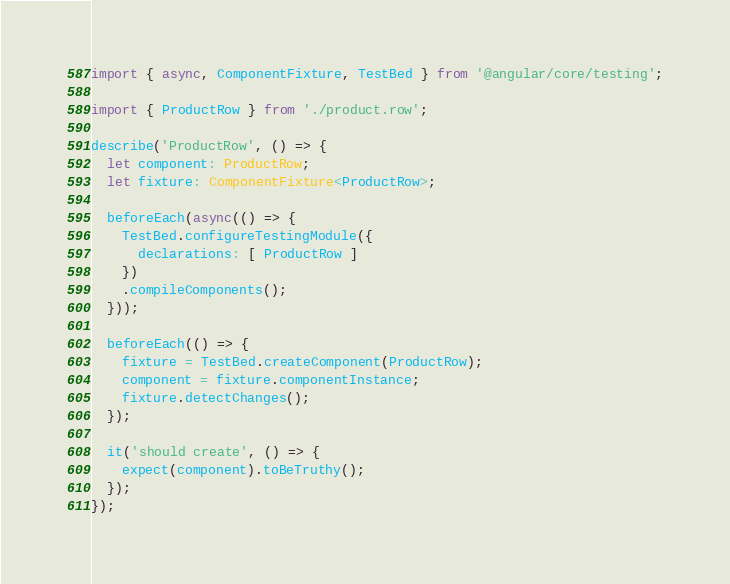<code> <loc_0><loc_0><loc_500><loc_500><_TypeScript_>import { async, ComponentFixture, TestBed } from '@angular/core/testing';

import { ProductRow } from './product.row';

describe('ProductRow', () => {
  let component: ProductRow;
  let fixture: ComponentFixture<ProductRow>;

  beforeEach(async(() => {
    TestBed.configureTestingModule({
      declarations: [ ProductRow ]
    })
    .compileComponents();
  }));

  beforeEach(() => {
    fixture = TestBed.createComponent(ProductRow);
    component = fixture.componentInstance;
    fixture.detectChanges();
  });

  it('should create', () => {
    expect(component).toBeTruthy();
  });
});
</code> 